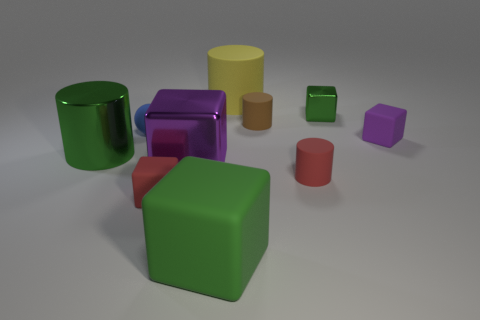Subtract all green shiny cylinders. How many cylinders are left? 3 Subtract all green cylinders. How many cylinders are left? 3 Subtract all cylinders. How many objects are left? 6 Subtract 1 blocks. How many blocks are left? 4 Subtract all blue cubes. Subtract all yellow spheres. How many cubes are left? 5 Subtract all blue blocks. How many green cylinders are left? 1 Subtract all large matte blocks. Subtract all small blue objects. How many objects are left? 8 Add 9 tiny red blocks. How many tiny red blocks are left? 10 Add 6 blue rubber spheres. How many blue rubber spheres exist? 7 Subtract 0 blue cylinders. How many objects are left? 10 